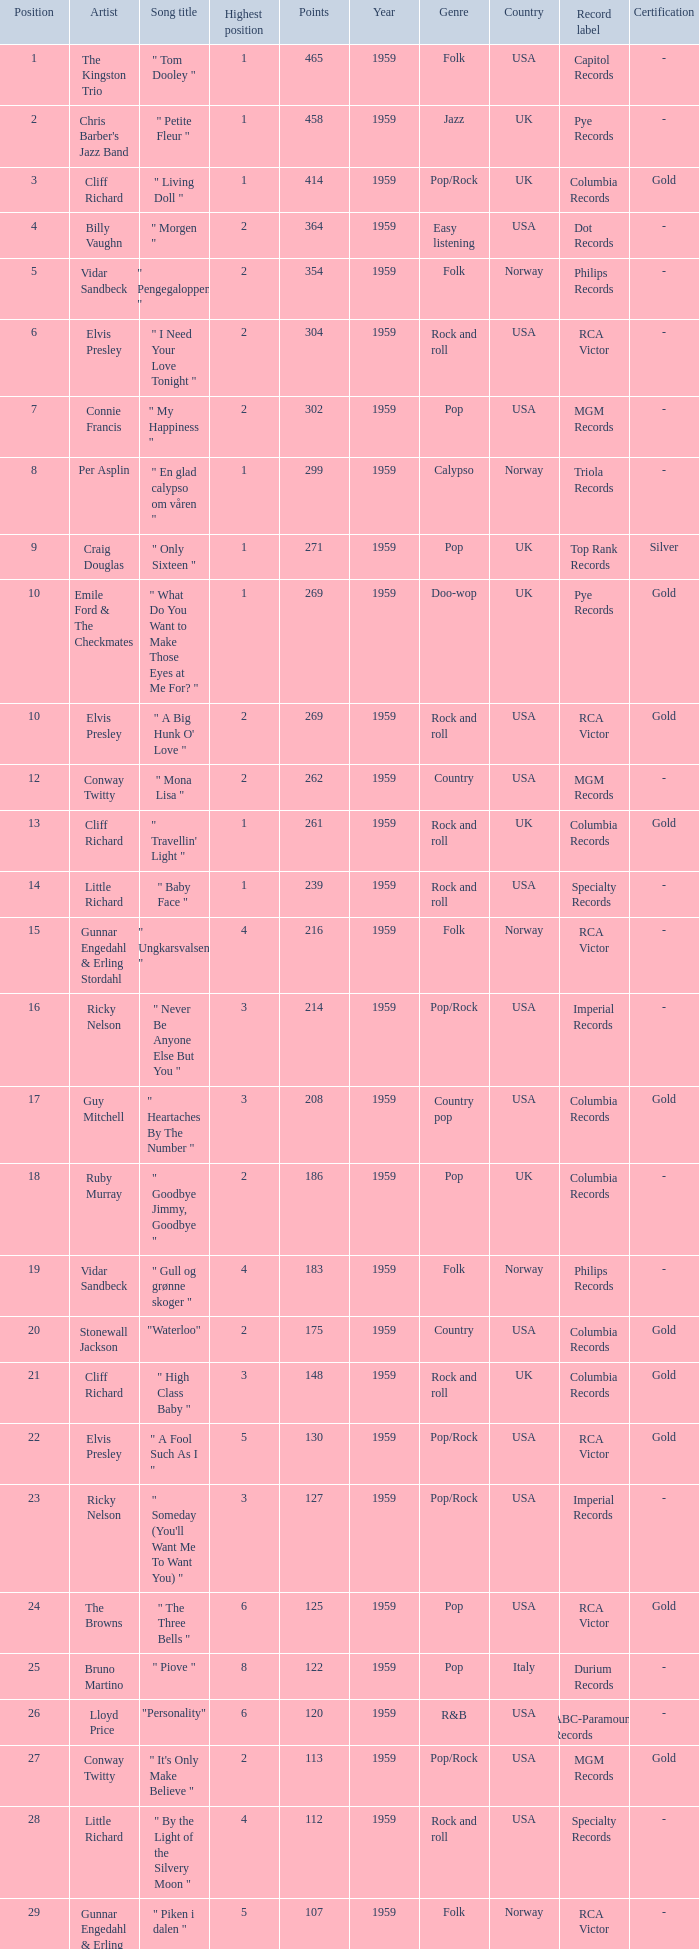What is the nme of the song performed by billy vaughn? " Morgen ". 